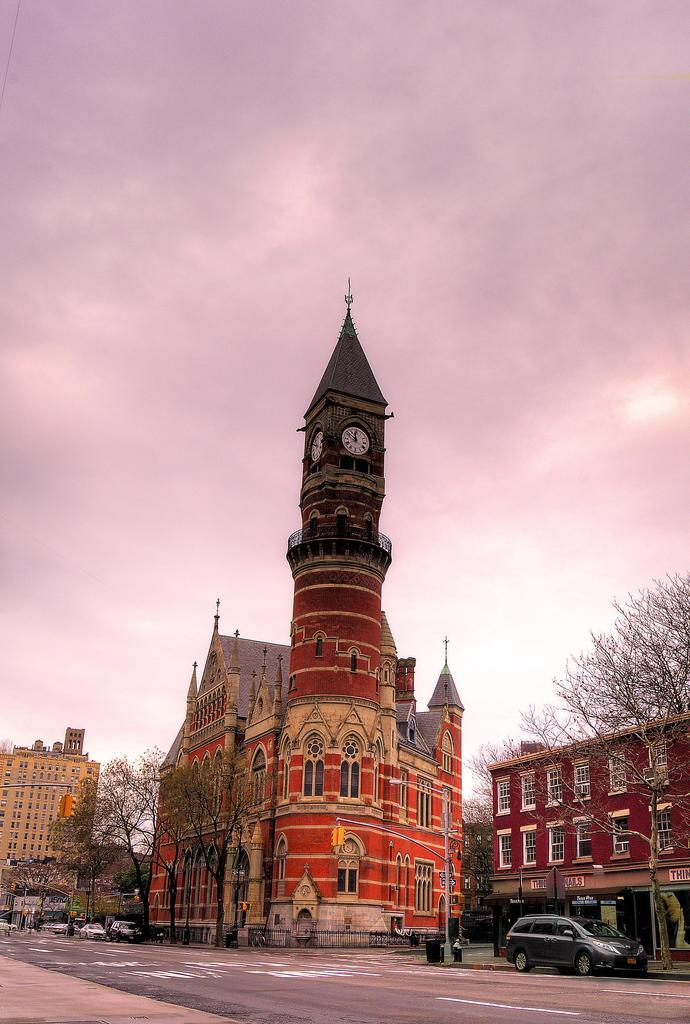What type of structures can be seen in the image? There are buildings in the image. What is located in front of the buildings? There are trees in front of the buildings. What is happening on the road beneath the trees? There are vehicles moving on the road beneath the trees. What can be seen in the background of the image? The sky is visible in the background of the image. How much money is being exchanged between the mother and child in the image? There is no mother or child present in the image, and therefore no money exchange can be observed. 